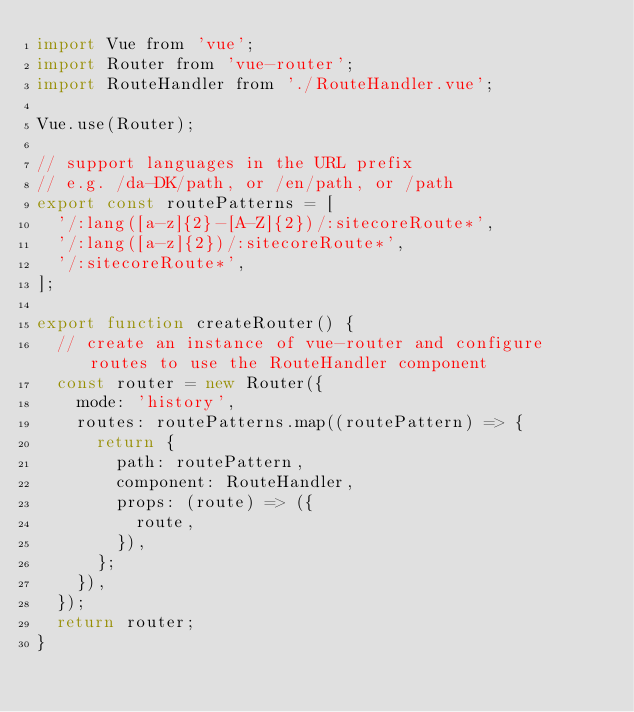Convert code to text. <code><loc_0><loc_0><loc_500><loc_500><_JavaScript_>import Vue from 'vue';
import Router from 'vue-router';
import RouteHandler from './RouteHandler.vue';

Vue.use(Router);

// support languages in the URL prefix
// e.g. /da-DK/path, or /en/path, or /path
export const routePatterns = [
  '/:lang([a-z]{2}-[A-Z]{2})/:sitecoreRoute*',
  '/:lang([a-z]{2})/:sitecoreRoute*',
  '/:sitecoreRoute*',
];

export function createRouter() {
  // create an instance of vue-router and configure routes to use the RouteHandler component
  const router = new Router({
    mode: 'history',
    routes: routePatterns.map((routePattern) => {
      return {
        path: routePattern,
        component: RouteHandler,
        props: (route) => ({
          route,
        }),
      };
    }),
  });
  return router;
}
</code> 